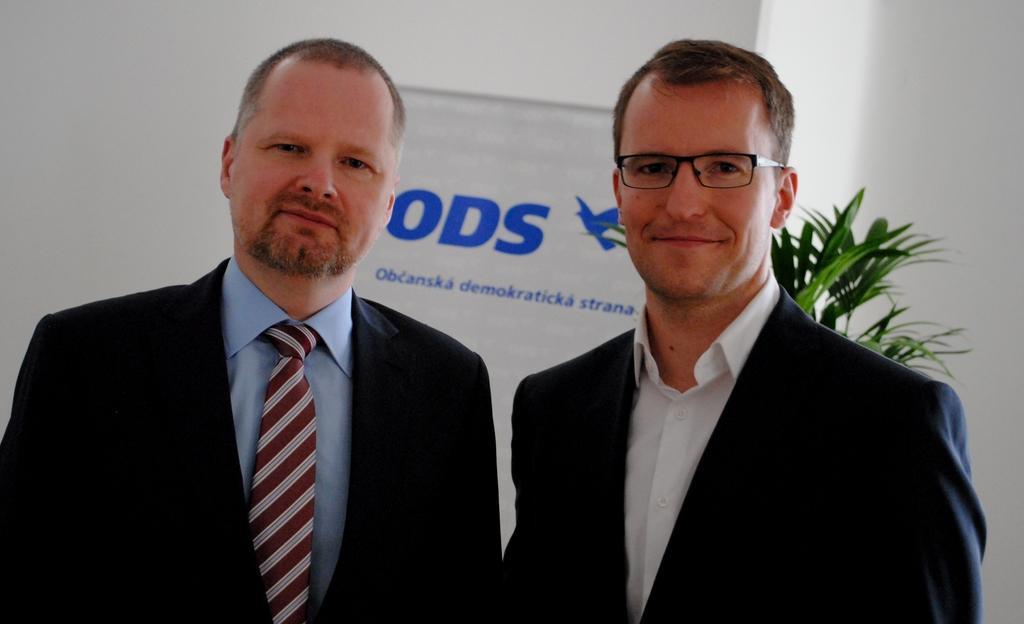Could you give a brief overview of what you see in this image? In this image we can see two men. On man is wearing a white shirt and coat. And the other man is wearing a blue shirt, tie and coat. In the background, we can see the wall, a plant and a board. 